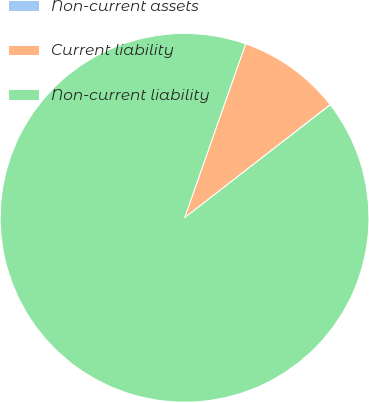Convert chart. <chart><loc_0><loc_0><loc_500><loc_500><pie_chart><fcel>Non-current assets<fcel>Current liability<fcel>Non-current liability<nl><fcel>0.03%<fcel>9.11%<fcel>90.86%<nl></chart> 